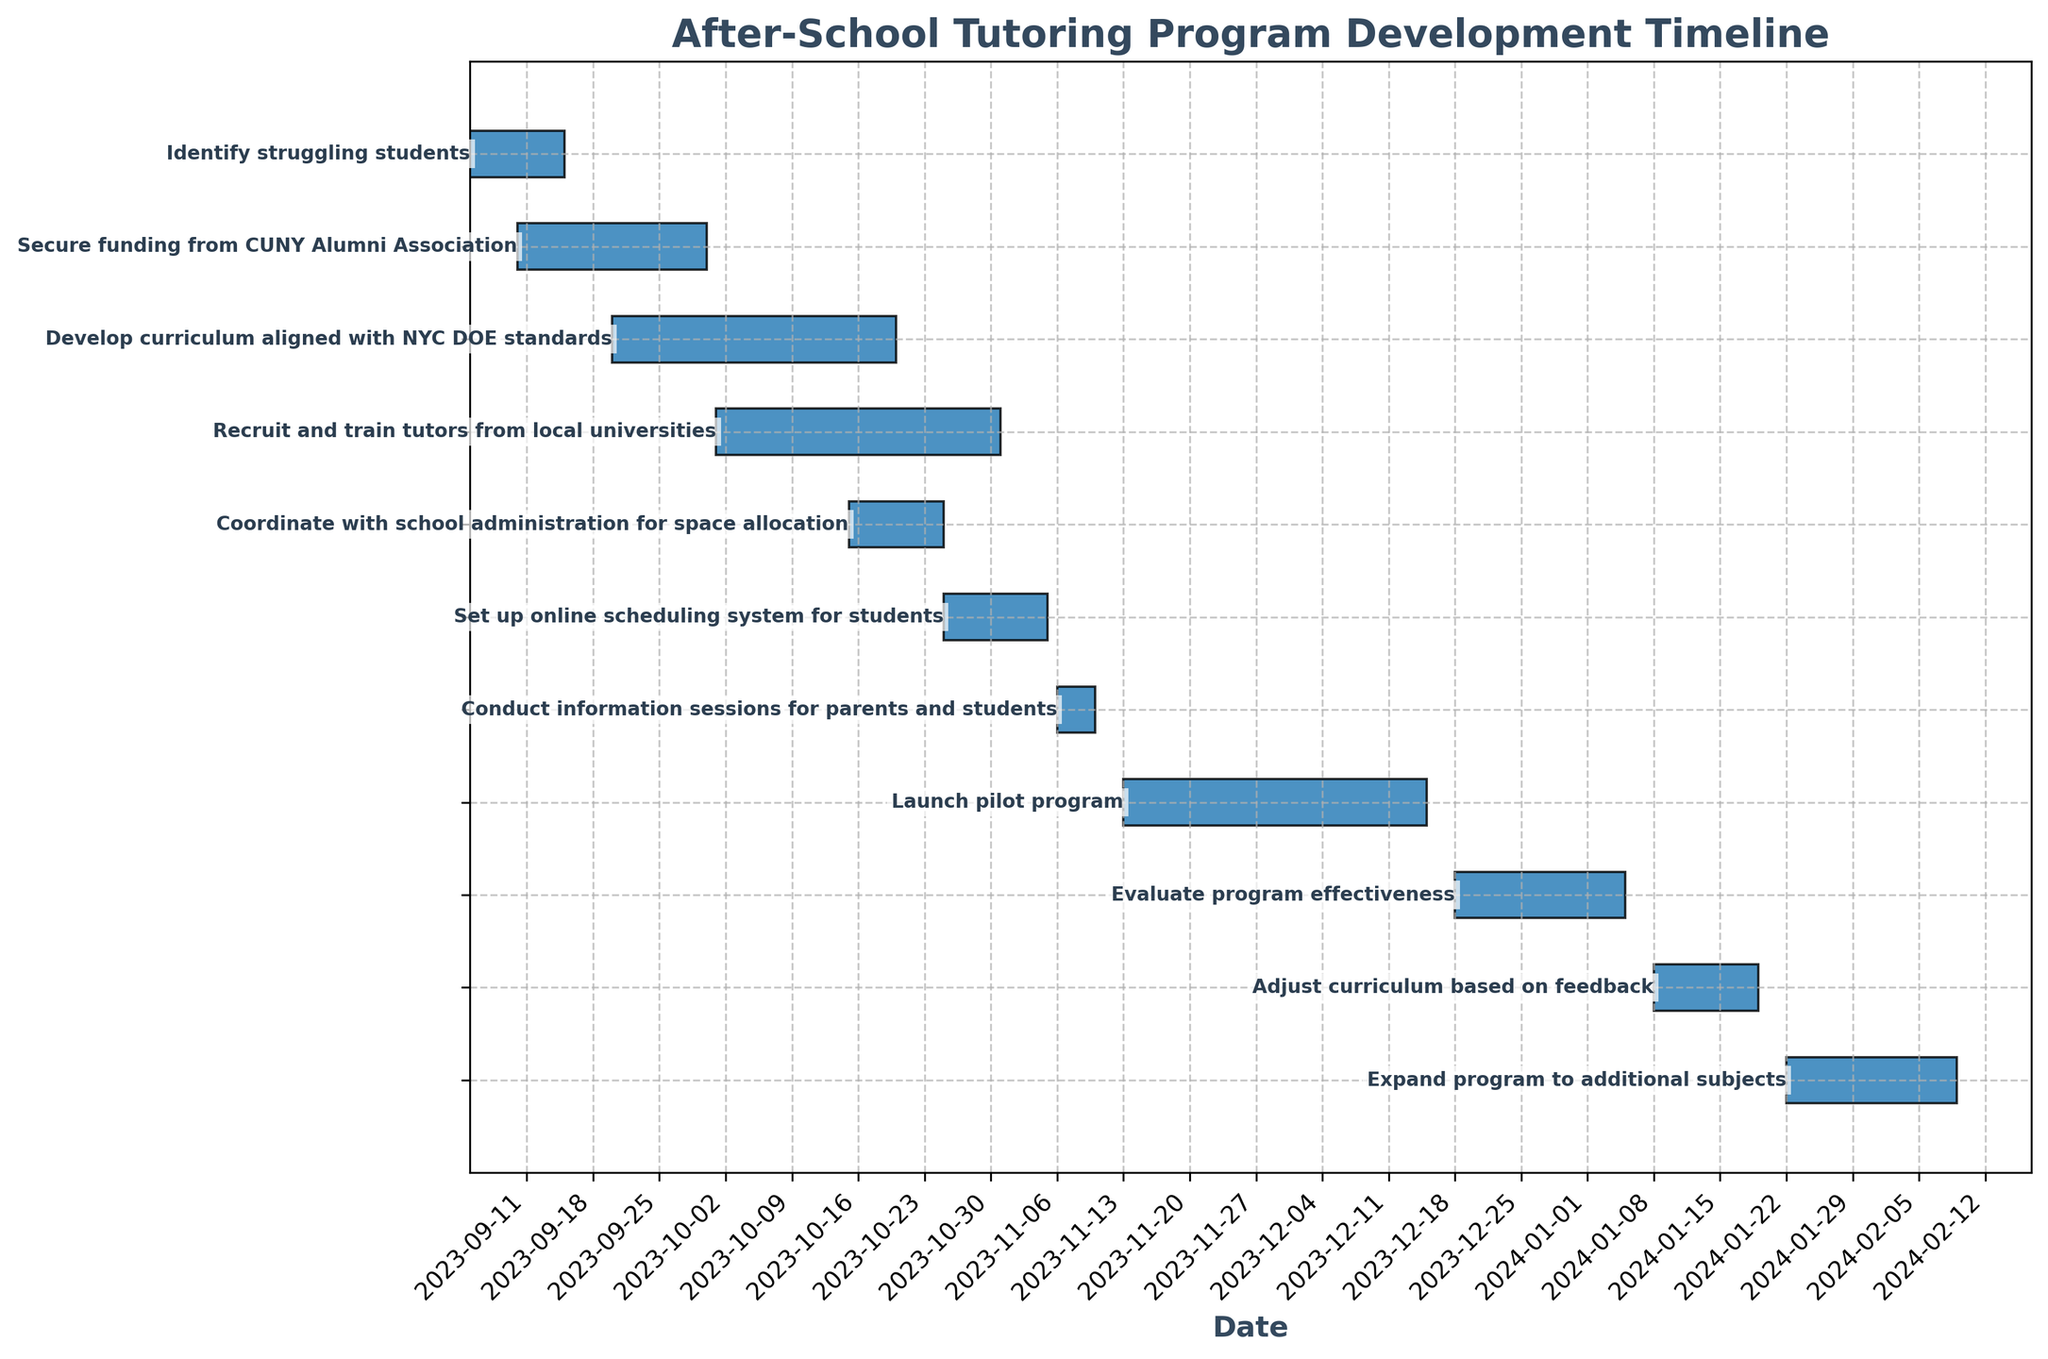What is the title of the chart? The title of the chart is located at the top. It's labeled "After-School Tutoring Program Development Timeline". This is the main descriptor of the Gantt Chart and provides context for the tasks and timelines presented.
Answer: After-School Tutoring Program Development Timeline How many tasks are represented in the Gantt Chart? Count each horizontal bar representing a task. Each task is labeled on the left side of the chart. By counting these labels, we can determine the total number of tasks.
Answer: 11 Which task has the longest duration? To find the task with the longest duration, measure the length of the horizontal bars. The longest bar corresponds to the longest task duration. From the figure, "Develop curriculum aligned with NYC DOE standards" and "Recruit and train tutors from local universities" both span 30 days.
Answer: Develop curriculum aligned with NYC DOE standards and Recruit and train tutors from local universities What is the time frame for the "Launch pilot program" task? Find the horizontal bar labeled "Launch pilot program" and note its start and end dates. This bar starts on 2023-11-13 and ends on 2023-12-15.
Answer: 2023-11-13 to 2023-12-15 Which task overlaps partially with "Coordinate with school administration for space allocation"? Find the task labeled "Coordinate with school administration for space allocation" and its corresponding dates. Then, identify any other bars that overlap with this time frame. The bar for "Recruit and train tutors from local universities" overlaps because both span dates between 2023-10-15 and 2023-10-25.
Answer: Recruit and train tutors from local universities How many tasks begin in October 2023? Identify the start dates of all tasks. Count how many tasks have their start dates in October 2023. The relevant tasks are "Develop curriculum aligned with NYC DOE standards", "Recruit and train tutors from local universities", and "Coordinate with school administration for space allocation".
Answer: 3 What is the combined duration of the tasks "Evaluate program effectiveness" and "Adjust curriculum based on feedback"? Find the duration of each task individually. "Evaluate program effectiveness" runs for 18 days and "Adjust curriculum based on feedback" runs for 11 days. Summing these gives 18 + 11 = 29 days.
Answer: 29 days Which task follows immediately after "Set up online scheduling system for students"? Identify the task that ends right before "Set up online scheduling system for students" ends. The "Set up online scheduling system for students" task ends on 2023-11-05. The next task labeled "Conduct information sessions for parents and students" begins on 2023-11-06.
Answer: Conduct information sessions for parents and students What is the end date for "Expand program to additional subjects"? Find the task labeled "Expand program to additional subjects" and locate its end date on the Gantt Chart. This task is set to end on 2024-02-09.
Answer: 2024-02-09 